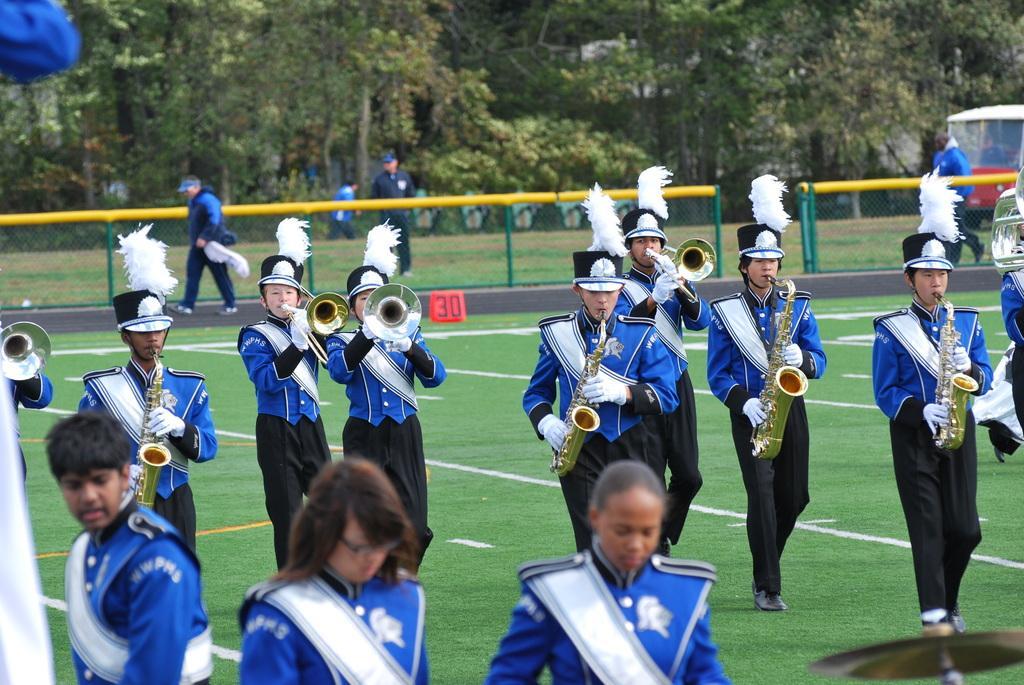Describe this image in one or two sentences. In the picture we can see group of people wearing blue and black color dress playing trumpet and walking along the ground and in the background there is fencing, there are some trees. 